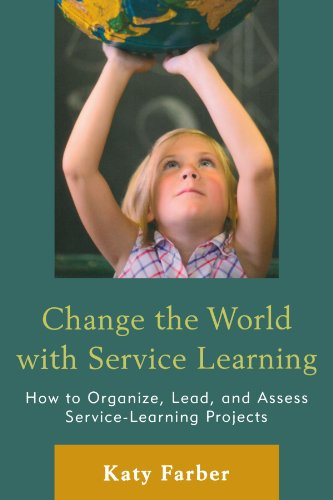What is the title of this book? The full title of the book shown is 'Change the World with Service Learning: How to Organize, Lead, and Assess Service-Learning Projects.' This guide offers comprehensive insights into implementing and managing service learning projects. 